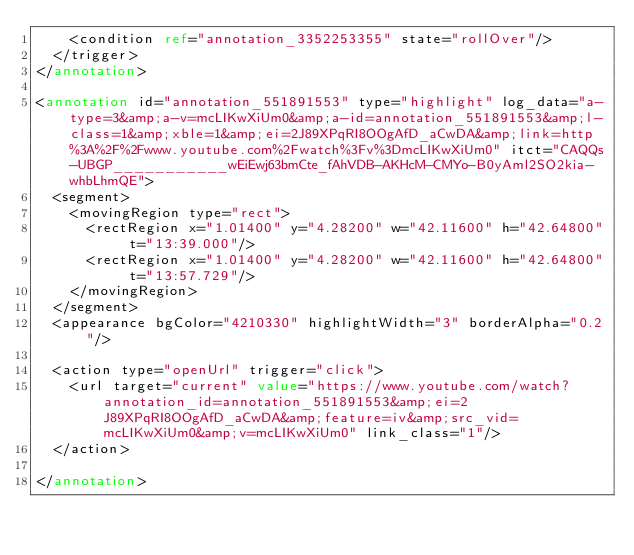Convert code to text. <code><loc_0><loc_0><loc_500><loc_500><_XML_>    <condition ref="annotation_3352253355" state="rollOver"/>
  </trigger>
</annotation>

<annotation id="annotation_551891553" type="highlight" log_data="a-type=3&amp;a-v=mcLIKwXiUm0&amp;a-id=annotation_551891553&amp;l-class=1&amp;xble=1&amp;ei=2J89XPqRI8OOgAfD_aCwDA&amp;link=http%3A%2F%2Fwww.youtube.com%2Fwatch%3Fv%3DmcLIKwXiUm0" itct="CAQQs-UBGP___________wEiEwj63bmCte_fAhVDB-AKHcM-CMYo-B0yAml2SO2kia-whbLhmQE">
  <segment>
    <movingRegion type="rect">
      <rectRegion x="1.01400" y="4.28200" w="42.11600" h="42.64800" t="13:39.000"/>
      <rectRegion x="1.01400" y="4.28200" w="42.11600" h="42.64800" t="13:57.729"/>
    </movingRegion>
  </segment>
  <appearance bgColor="4210330" highlightWidth="3" borderAlpha="0.2"/>
  
  <action type="openUrl" trigger="click">
    <url target="current" value="https://www.youtube.com/watch?annotation_id=annotation_551891553&amp;ei=2J89XPqRI8OOgAfD_aCwDA&amp;feature=iv&amp;src_vid=mcLIKwXiUm0&amp;v=mcLIKwXiUm0" link_class="1"/>
  </action>

</annotation>
</code> 